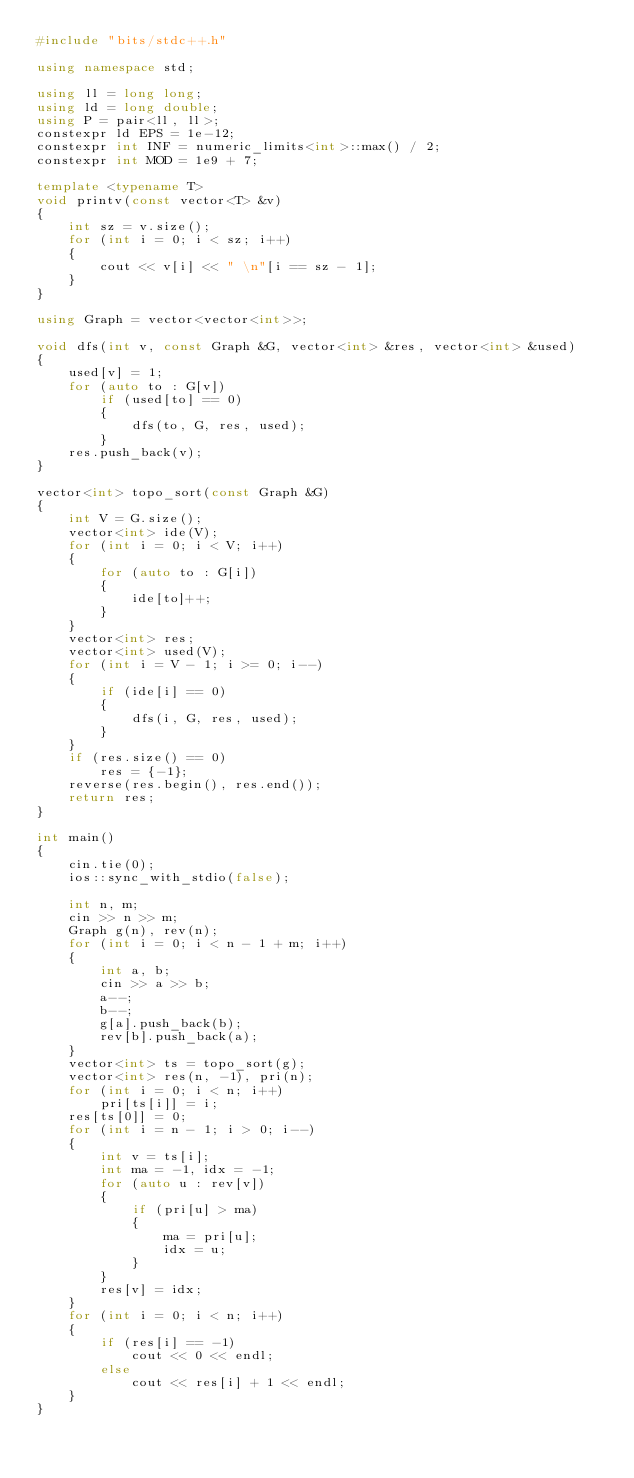Convert code to text. <code><loc_0><loc_0><loc_500><loc_500><_C++_>#include "bits/stdc++.h"

using namespace std;

using ll = long long;
using ld = long double;
using P = pair<ll, ll>;
constexpr ld EPS = 1e-12;
constexpr int INF = numeric_limits<int>::max() / 2;
constexpr int MOD = 1e9 + 7;

template <typename T>
void printv(const vector<T> &v)
{
    int sz = v.size();
    for (int i = 0; i < sz; i++)
    {
        cout << v[i] << " \n"[i == sz - 1];
    }
}

using Graph = vector<vector<int>>;

void dfs(int v, const Graph &G, vector<int> &res, vector<int> &used)
{
    used[v] = 1;
    for (auto to : G[v])
        if (used[to] == 0)
        {
            dfs(to, G, res, used);
        }
    res.push_back(v);
}

vector<int> topo_sort(const Graph &G)
{
    int V = G.size();
    vector<int> ide(V);
    for (int i = 0; i < V; i++)
    {
        for (auto to : G[i])
        {
            ide[to]++;
        }
    }
    vector<int> res;
    vector<int> used(V);
    for (int i = V - 1; i >= 0; i--)
    {
        if (ide[i] == 0)
        {
            dfs(i, G, res, used);
        }
    }
    if (res.size() == 0)
        res = {-1};
    reverse(res.begin(), res.end());
    return res;
}

int main()
{
    cin.tie(0);
    ios::sync_with_stdio(false);

    int n, m;
    cin >> n >> m;
    Graph g(n), rev(n);
    for (int i = 0; i < n - 1 + m; i++)
    {
        int a, b;
        cin >> a >> b;
        a--;
        b--;
        g[a].push_back(b);
        rev[b].push_back(a);
    }
    vector<int> ts = topo_sort(g);
    vector<int> res(n, -1), pri(n);
    for (int i = 0; i < n; i++)
        pri[ts[i]] = i;
    res[ts[0]] = 0;
    for (int i = n - 1; i > 0; i--)
    {
        int v = ts[i];
        int ma = -1, idx = -1;
        for (auto u : rev[v])
        {
            if (pri[u] > ma)
            {
                ma = pri[u];
                idx = u;
            }
        }
        res[v] = idx;
    }
    for (int i = 0; i < n; i++)
    {
        if (res[i] == -1)
            cout << 0 << endl;
        else
            cout << res[i] + 1 << endl;
    }
}
</code> 